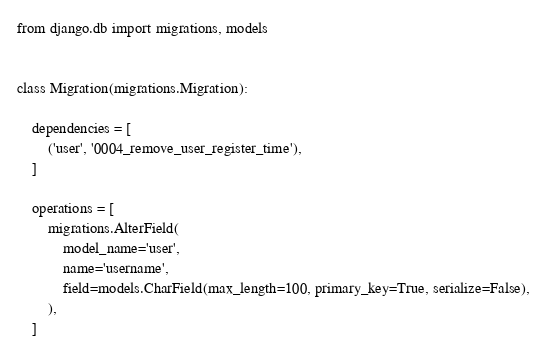<code> <loc_0><loc_0><loc_500><loc_500><_Python_>from django.db import migrations, models


class Migration(migrations.Migration):

    dependencies = [
        ('user', '0004_remove_user_register_time'),
    ]

    operations = [
        migrations.AlterField(
            model_name='user',
            name='username',
            field=models.CharField(max_length=100, primary_key=True, serialize=False),
        ),
    ]
</code> 